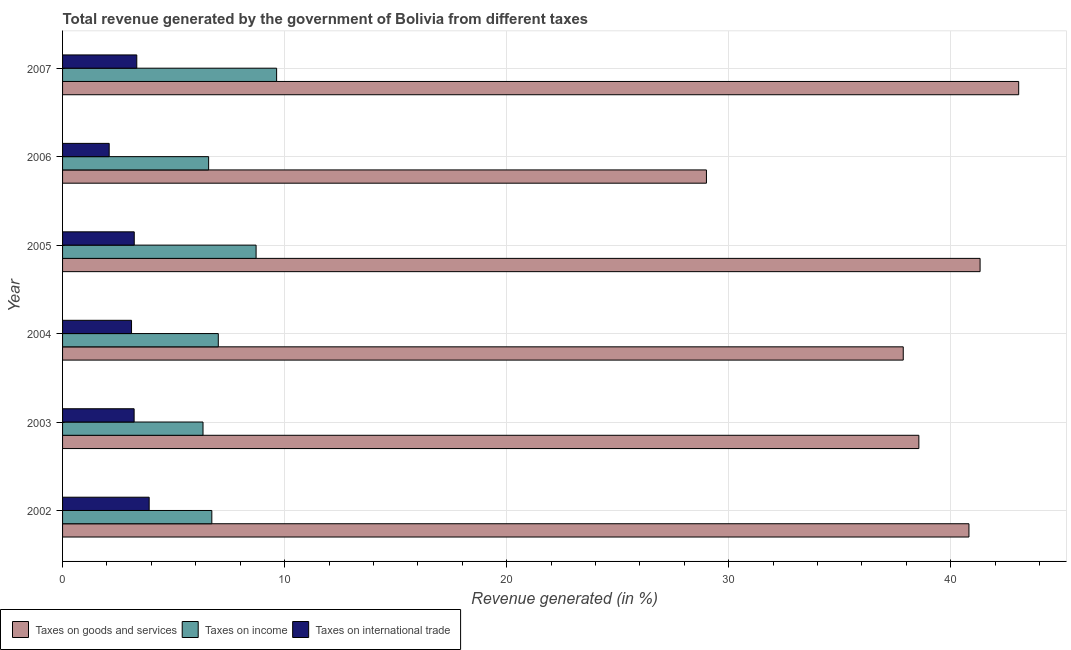How many different coloured bars are there?
Your answer should be very brief. 3. How many groups of bars are there?
Provide a succinct answer. 6. Are the number of bars on each tick of the Y-axis equal?
Give a very brief answer. Yes. How many bars are there on the 6th tick from the bottom?
Provide a succinct answer. 3. What is the label of the 2nd group of bars from the top?
Keep it short and to the point. 2006. What is the percentage of revenue generated by tax on international trade in 2003?
Your answer should be compact. 3.22. Across all years, what is the maximum percentage of revenue generated by taxes on goods and services?
Offer a very short reply. 43.06. Across all years, what is the minimum percentage of revenue generated by taxes on goods and services?
Your response must be concise. 29. What is the total percentage of revenue generated by taxes on income in the graph?
Ensure brevity in your answer.  45. What is the difference between the percentage of revenue generated by taxes on income in 2005 and that in 2007?
Your answer should be very brief. -0.93. What is the difference between the percentage of revenue generated by tax on international trade in 2006 and the percentage of revenue generated by taxes on income in 2005?
Give a very brief answer. -6.62. What is the average percentage of revenue generated by taxes on goods and services per year?
Give a very brief answer. 38.44. In the year 2006, what is the difference between the percentage of revenue generated by taxes on goods and services and percentage of revenue generated by taxes on income?
Provide a short and direct response. 22.42. In how many years, is the percentage of revenue generated by taxes on goods and services greater than 34 %?
Your response must be concise. 5. What is the ratio of the percentage of revenue generated by tax on international trade in 2005 to that in 2006?
Give a very brief answer. 1.54. What is the difference between the highest and the second highest percentage of revenue generated by tax on international trade?
Your response must be concise. 0.56. What is the difference between the highest and the lowest percentage of revenue generated by taxes on income?
Your response must be concise. 3.32. What does the 2nd bar from the top in 2006 represents?
Give a very brief answer. Taxes on income. What does the 2nd bar from the bottom in 2007 represents?
Your answer should be very brief. Taxes on income. What is the difference between two consecutive major ticks on the X-axis?
Your answer should be very brief. 10. Are the values on the major ticks of X-axis written in scientific E-notation?
Provide a succinct answer. No. How many legend labels are there?
Provide a succinct answer. 3. What is the title of the graph?
Provide a succinct answer. Total revenue generated by the government of Bolivia from different taxes. Does "Taxes" appear as one of the legend labels in the graph?
Your response must be concise. No. What is the label or title of the X-axis?
Make the answer very short. Revenue generated (in %). What is the label or title of the Y-axis?
Give a very brief answer. Year. What is the Revenue generated (in %) in Taxes on goods and services in 2002?
Offer a terse response. 40.82. What is the Revenue generated (in %) in Taxes on income in 2002?
Your answer should be very brief. 6.72. What is the Revenue generated (in %) in Taxes on international trade in 2002?
Offer a very short reply. 3.9. What is the Revenue generated (in %) in Taxes on goods and services in 2003?
Offer a very short reply. 38.57. What is the Revenue generated (in %) of Taxes on income in 2003?
Provide a short and direct response. 6.33. What is the Revenue generated (in %) of Taxes on international trade in 2003?
Your answer should be compact. 3.22. What is the Revenue generated (in %) in Taxes on goods and services in 2004?
Provide a succinct answer. 37.86. What is the Revenue generated (in %) of Taxes on income in 2004?
Offer a terse response. 7.01. What is the Revenue generated (in %) in Taxes on international trade in 2004?
Offer a very short reply. 3.11. What is the Revenue generated (in %) of Taxes on goods and services in 2005?
Offer a terse response. 41.32. What is the Revenue generated (in %) in Taxes on income in 2005?
Ensure brevity in your answer.  8.72. What is the Revenue generated (in %) of Taxes on international trade in 2005?
Make the answer very short. 3.23. What is the Revenue generated (in %) in Taxes on goods and services in 2006?
Provide a succinct answer. 29. What is the Revenue generated (in %) in Taxes on income in 2006?
Provide a short and direct response. 6.58. What is the Revenue generated (in %) of Taxes on international trade in 2006?
Offer a terse response. 2.1. What is the Revenue generated (in %) of Taxes on goods and services in 2007?
Make the answer very short. 43.06. What is the Revenue generated (in %) in Taxes on income in 2007?
Give a very brief answer. 9.64. What is the Revenue generated (in %) in Taxes on international trade in 2007?
Your response must be concise. 3.34. Across all years, what is the maximum Revenue generated (in %) in Taxes on goods and services?
Offer a very short reply. 43.06. Across all years, what is the maximum Revenue generated (in %) in Taxes on income?
Offer a very short reply. 9.64. Across all years, what is the maximum Revenue generated (in %) in Taxes on international trade?
Give a very brief answer. 3.9. Across all years, what is the minimum Revenue generated (in %) in Taxes on goods and services?
Your answer should be compact. 29. Across all years, what is the minimum Revenue generated (in %) in Taxes on income?
Provide a succinct answer. 6.33. Across all years, what is the minimum Revenue generated (in %) in Taxes on international trade?
Your answer should be very brief. 2.1. What is the total Revenue generated (in %) of Taxes on goods and services in the graph?
Your response must be concise. 230.64. What is the total Revenue generated (in %) in Taxes on income in the graph?
Your response must be concise. 45. What is the total Revenue generated (in %) in Taxes on international trade in the graph?
Keep it short and to the point. 18.9. What is the difference between the Revenue generated (in %) in Taxes on goods and services in 2002 and that in 2003?
Make the answer very short. 2.26. What is the difference between the Revenue generated (in %) of Taxes on income in 2002 and that in 2003?
Provide a succinct answer. 0.4. What is the difference between the Revenue generated (in %) in Taxes on international trade in 2002 and that in 2003?
Provide a short and direct response. 0.68. What is the difference between the Revenue generated (in %) in Taxes on goods and services in 2002 and that in 2004?
Offer a very short reply. 2.96. What is the difference between the Revenue generated (in %) of Taxes on income in 2002 and that in 2004?
Your response must be concise. -0.29. What is the difference between the Revenue generated (in %) of Taxes on international trade in 2002 and that in 2004?
Give a very brief answer. 0.79. What is the difference between the Revenue generated (in %) of Taxes on goods and services in 2002 and that in 2005?
Your answer should be compact. -0.5. What is the difference between the Revenue generated (in %) in Taxes on income in 2002 and that in 2005?
Your answer should be compact. -1.99. What is the difference between the Revenue generated (in %) in Taxes on international trade in 2002 and that in 2005?
Make the answer very short. 0.67. What is the difference between the Revenue generated (in %) of Taxes on goods and services in 2002 and that in 2006?
Ensure brevity in your answer.  11.82. What is the difference between the Revenue generated (in %) in Taxes on income in 2002 and that in 2006?
Your answer should be compact. 0.14. What is the difference between the Revenue generated (in %) of Taxes on international trade in 2002 and that in 2006?
Provide a short and direct response. 1.8. What is the difference between the Revenue generated (in %) of Taxes on goods and services in 2002 and that in 2007?
Give a very brief answer. -2.24. What is the difference between the Revenue generated (in %) of Taxes on income in 2002 and that in 2007?
Ensure brevity in your answer.  -2.92. What is the difference between the Revenue generated (in %) of Taxes on international trade in 2002 and that in 2007?
Keep it short and to the point. 0.56. What is the difference between the Revenue generated (in %) of Taxes on goods and services in 2003 and that in 2004?
Keep it short and to the point. 0.7. What is the difference between the Revenue generated (in %) of Taxes on income in 2003 and that in 2004?
Offer a terse response. -0.69. What is the difference between the Revenue generated (in %) in Taxes on international trade in 2003 and that in 2004?
Offer a very short reply. 0.12. What is the difference between the Revenue generated (in %) of Taxes on goods and services in 2003 and that in 2005?
Give a very brief answer. -2.76. What is the difference between the Revenue generated (in %) in Taxes on income in 2003 and that in 2005?
Provide a succinct answer. -2.39. What is the difference between the Revenue generated (in %) in Taxes on international trade in 2003 and that in 2005?
Offer a terse response. -0.01. What is the difference between the Revenue generated (in %) in Taxes on goods and services in 2003 and that in 2006?
Your response must be concise. 9.57. What is the difference between the Revenue generated (in %) in Taxes on income in 2003 and that in 2006?
Offer a very short reply. -0.25. What is the difference between the Revenue generated (in %) in Taxes on international trade in 2003 and that in 2006?
Provide a succinct answer. 1.12. What is the difference between the Revenue generated (in %) in Taxes on goods and services in 2003 and that in 2007?
Keep it short and to the point. -4.5. What is the difference between the Revenue generated (in %) in Taxes on income in 2003 and that in 2007?
Your answer should be very brief. -3.32. What is the difference between the Revenue generated (in %) of Taxes on international trade in 2003 and that in 2007?
Offer a terse response. -0.12. What is the difference between the Revenue generated (in %) of Taxes on goods and services in 2004 and that in 2005?
Your answer should be very brief. -3.46. What is the difference between the Revenue generated (in %) of Taxes on income in 2004 and that in 2005?
Your answer should be compact. -1.7. What is the difference between the Revenue generated (in %) in Taxes on international trade in 2004 and that in 2005?
Offer a very short reply. -0.12. What is the difference between the Revenue generated (in %) of Taxes on goods and services in 2004 and that in 2006?
Provide a short and direct response. 8.86. What is the difference between the Revenue generated (in %) in Taxes on income in 2004 and that in 2006?
Ensure brevity in your answer.  0.44. What is the difference between the Revenue generated (in %) of Taxes on goods and services in 2004 and that in 2007?
Your answer should be compact. -5.2. What is the difference between the Revenue generated (in %) of Taxes on income in 2004 and that in 2007?
Offer a very short reply. -2.63. What is the difference between the Revenue generated (in %) in Taxes on international trade in 2004 and that in 2007?
Your answer should be compact. -0.24. What is the difference between the Revenue generated (in %) in Taxes on goods and services in 2005 and that in 2006?
Offer a terse response. 12.32. What is the difference between the Revenue generated (in %) in Taxes on income in 2005 and that in 2006?
Provide a succinct answer. 2.14. What is the difference between the Revenue generated (in %) of Taxes on international trade in 2005 and that in 2006?
Provide a succinct answer. 1.13. What is the difference between the Revenue generated (in %) of Taxes on goods and services in 2005 and that in 2007?
Your answer should be compact. -1.74. What is the difference between the Revenue generated (in %) in Taxes on income in 2005 and that in 2007?
Make the answer very short. -0.93. What is the difference between the Revenue generated (in %) in Taxes on international trade in 2005 and that in 2007?
Your answer should be compact. -0.11. What is the difference between the Revenue generated (in %) of Taxes on goods and services in 2006 and that in 2007?
Provide a succinct answer. -14.06. What is the difference between the Revenue generated (in %) in Taxes on income in 2006 and that in 2007?
Give a very brief answer. -3.06. What is the difference between the Revenue generated (in %) in Taxes on international trade in 2006 and that in 2007?
Give a very brief answer. -1.24. What is the difference between the Revenue generated (in %) in Taxes on goods and services in 2002 and the Revenue generated (in %) in Taxes on income in 2003?
Keep it short and to the point. 34.5. What is the difference between the Revenue generated (in %) in Taxes on goods and services in 2002 and the Revenue generated (in %) in Taxes on international trade in 2003?
Keep it short and to the point. 37.6. What is the difference between the Revenue generated (in %) of Taxes on income in 2002 and the Revenue generated (in %) of Taxes on international trade in 2003?
Your answer should be very brief. 3.5. What is the difference between the Revenue generated (in %) in Taxes on goods and services in 2002 and the Revenue generated (in %) in Taxes on income in 2004?
Ensure brevity in your answer.  33.81. What is the difference between the Revenue generated (in %) of Taxes on goods and services in 2002 and the Revenue generated (in %) of Taxes on international trade in 2004?
Your answer should be compact. 37.72. What is the difference between the Revenue generated (in %) of Taxes on income in 2002 and the Revenue generated (in %) of Taxes on international trade in 2004?
Make the answer very short. 3.62. What is the difference between the Revenue generated (in %) of Taxes on goods and services in 2002 and the Revenue generated (in %) of Taxes on income in 2005?
Your answer should be very brief. 32.11. What is the difference between the Revenue generated (in %) of Taxes on goods and services in 2002 and the Revenue generated (in %) of Taxes on international trade in 2005?
Offer a very short reply. 37.59. What is the difference between the Revenue generated (in %) of Taxes on income in 2002 and the Revenue generated (in %) of Taxes on international trade in 2005?
Your response must be concise. 3.49. What is the difference between the Revenue generated (in %) of Taxes on goods and services in 2002 and the Revenue generated (in %) of Taxes on income in 2006?
Provide a succinct answer. 34.24. What is the difference between the Revenue generated (in %) of Taxes on goods and services in 2002 and the Revenue generated (in %) of Taxes on international trade in 2006?
Your answer should be very brief. 38.72. What is the difference between the Revenue generated (in %) in Taxes on income in 2002 and the Revenue generated (in %) in Taxes on international trade in 2006?
Offer a terse response. 4.62. What is the difference between the Revenue generated (in %) of Taxes on goods and services in 2002 and the Revenue generated (in %) of Taxes on income in 2007?
Give a very brief answer. 31.18. What is the difference between the Revenue generated (in %) in Taxes on goods and services in 2002 and the Revenue generated (in %) in Taxes on international trade in 2007?
Offer a very short reply. 37.48. What is the difference between the Revenue generated (in %) in Taxes on income in 2002 and the Revenue generated (in %) in Taxes on international trade in 2007?
Ensure brevity in your answer.  3.38. What is the difference between the Revenue generated (in %) of Taxes on goods and services in 2003 and the Revenue generated (in %) of Taxes on income in 2004?
Offer a terse response. 31.55. What is the difference between the Revenue generated (in %) of Taxes on goods and services in 2003 and the Revenue generated (in %) of Taxes on international trade in 2004?
Offer a terse response. 35.46. What is the difference between the Revenue generated (in %) of Taxes on income in 2003 and the Revenue generated (in %) of Taxes on international trade in 2004?
Give a very brief answer. 3.22. What is the difference between the Revenue generated (in %) in Taxes on goods and services in 2003 and the Revenue generated (in %) in Taxes on income in 2005?
Provide a short and direct response. 29.85. What is the difference between the Revenue generated (in %) of Taxes on goods and services in 2003 and the Revenue generated (in %) of Taxes on international trade in 2005?
Provide a succinct answer. 35.34. What is the difference between the Revenue generated (in %) of Taxes on income in 2003 and the Revenue generated (in %) of Taxes on international trade in 2005?
Offer a terse response. 3.1. What is the difference between the Revenue generated (in %) of Taxes on goods and services in 2003 and the Revenue generated (in %) of Taxes on income in 2006?
Ensure brevity in your answer.  31.99. What is the difference between the Revenue generated (in %) of Taxes on goods and services in 2003 and the Revenue generated (in %) of Taxes on international trade in 2006?
Give a very brief answer. 36.47. What is the difference between the Revenue generated (in %) of Taxes on income in 2003 and the Revenue generated (in %) of Taxes on international trade in 2006?
Your answer should be compact. 4.23. What is the difference between the Revenue generated (in %) of Taxes on goods and services in 2003 and the Revenue generated (in %) of Taxes on income in 2007?
Ensure brevity in your answer.  28.93. What is the difference between the Revenue generated (in %) of Taxes on goods and services in 2003 and the Revenue generated (in %) of Taxes on international trade in 2007?
Offer a very short reply. 35.22. What is the difference between the Revenue generated (in %) in Taxes on income in 2003 and the Revenue generated (in %) in Taxes on international trade in 2007?
Keep it short and to the point. 2.98. What is the difference between the Revenue generated (in %) of Taxes on goods and services in 2004 and the Revenue generated (in %) of Taxes on income in 2005?
Provide a succinct answer. 29.15. What is the difference between the Revenue generated (in %) in Taxes on goods and services in 2004 and the Revenue generated (in %) in Taxes on international trade in 2005?
Your answer should be compact. 34.63. What is the difference between the Revenue generated (in %) of Taxes on income in 2004 and the Revenue generated (in %) of Taxes on international trade in 2005?
Your response must be concise. 3.79. What is the difference between the Revenue generated (in %) of Taxes on goods and services in 2004 and the Revenue generated (in %) of Taxes on income in 2006?
Offer a very short reply. 31.28. What is the difference between the Revenue generated (in %) of Taxes on goods and services in 2004 and the Revenue generated (in %) of Taxes on international trade in 2006?
Offer a terse response. 35.76. What is the difference between the Revenue generated (in %) of Taxes on income in 2004 and the Revenue generated (in %) of Taxes on international trade in 2006?
Offer a very short reply. 4.91. What is the difference between the Revenue generated (in %) in Taxes on goods and services in 2004 and the Revenue generated (in %) in Taxes on income in 2007?
Offer a very short reply. 28.22. What is the difference between the Revenue generated (in %) in Taxes on goods and services in 2004 and the Revenue generated (in %) in Taxes on international trade in 2007?
Keep it short and to the point. 34.52. What is the difference between the Revenue generated (in %) of Taxes on income in 2004 and the Revenue generated (in %) of Taxes on international trade in 2007?
Offer a very short reply. 3.67. What is the difference between the Revenue generated (in %) of Taxes on goods and services in 2005 and the Revenue generated (in %) of Taxes on income in 2006?
Offer a terse response. 34.75. What is the difference between the Revenue generated (in %) in Taxes on goods and services in 2005 and the Revenue generated (in %) in Taxes on international trade in 2006?
Offer a very short reply. 39.22. What is the difference between the Revenue generated (in %) of Taxes on income in 2005 and the Revenue generated (in %) of Taxes on international trade in 2006?
Your answer should be compact. 6.62. What is the difference between the Revenue generated (in %) in Taxes on goods and services in 2005 and the Revenue generated (in %) in Taxes on income in 2007?
Offer a terse response. 31.68. What is the difference between the Revenue generated (in %) in Taxes on goods and services in 2005 and the Revenue generated (in %) in Taxes on international trade in 2007?
Give a very brief answer. 37.98. What is the difference between the Revenue generated (in %) of Taxes on income in 2005 and the Revenue generated (in %) of Taxes on international trade in 2007?
Keep it short and to the point. 5.37. What is the difference between the Revenue generated (in %) of Taxes on goods and services in 2006 and the Revenue generated (in %) of Taxes on income in 2007?
Keep it short and to the point. 19.36. What is the difference between the Revenue generated (in %) in Taxes on goods and services in 2006 and the Revenue generated (in %) in Taxes on international trade in 2007?
Provide a succinct answer. 25.66. What is the difference between the Revenue generated (in %) of Taxes on income in 2006 and the Revenue generated (in %) of Taxes on international trade in 2007?
Make the answer very short. 3.24. What is the average Revenue generated (in %) of Taxes on goods and services per year?
Keep it short and to the point. 38.44. What is the average Revenue generated (in %) in Taxes on income per year?
Provide a short and direct response. 7.5. What is the average Revenue generated (in %) in Taxes on international trade per year?
Your answer should be very brief. 3.15. In the year 2002, what is the difference between the Revenue generated (in %) of Taxes on goods and services and Revenue generated (in %) of Taxes on income?
Offer a terse response. 34.1. In the year 2002, what is the difference between the Revenue generated (in %) in Taxes on goods and services and Revenue generated (in %) in Taxes on international trade?
Give a very brief answer. 36.92. In the year 2002, what is the difference between the Revenue generated (in %) of Taxes on income and Revenue generated (in %) of Taxes on international trade?
Provide a short and direct response. 2.82. In the year 2003, what is the difference between the Revenue generated (in %) in Taxes on goods and services and Revenue generated (in %) in Taxes on income?
Ensure brevity in your answer.  32.24. In the year 2003, what is the difference between the Revenue generated (in %) in Taxes on goods and services and Revenue generated (in %) in Taxes on international trade?
Ensure brevity in your answer.  35.34. In the year 2003, what is the difference between the Revenue generated (in %) of Taxes on income and Revenue generated (in %) of Taxes on international trade?
Give a very brief answer. 3.1. In the year 2004, what is the difference between the Revenue generated (in %) in Taxes on goods and services and Revenue generated (in %) in Taxes on income?
Provide a succinct answer. 30.85. In the year 2004, what is the difference between the Revenue generated (in %) of Taxes on goods and services and Revenue generated (in %) of Taxes on international trade?
Provide a succinct answer. 34.76. In the year 2004, what is the difference between the Revenue generated (in %) in Taxes on income and Revenue generated (in %) in Taxes on international trade?
Your answer should be very brief. 3.91. In the year 2005, what is the difference between the Revenue generated (in %) in Taxes on goods and services and Revenue generated (in %) in Taxes on income?
Provide a succinct answer. 32.61. In the year 2005, what is the difference between the Revenue generated (in %) in Taxes on goods and services and Revenue generated (in %) in Taxes on international trade?
Your answer should be very brief. 38.09. In the year 2005, what is the difference between the Revenue generated (in %) of Taxes on income and Revenue generated (in %) of Taxes on international trade?
Give a very brief answer. 5.49. In the year 2006, what is the difference between the Revenue generated (in %) of Taxes on goods and services and Revenue generated (in %) of Taxes on income?
Make the answer very short. 22.42. In the year 2006, what is the difference between the Revenue generated (in %) of Taxes on goods and services and Revenue generated (in %) of Taxes on international trade?
Offer a terse response. 26.9. In the year 2006, what is the difference between the Revenue generated (in %) of Taxes on income and Revenue generated (in %) of Taxes on international trade?
Provide a succinct answer. 4.48. In the year 2007, what is the difference between the Revenue generated (in %) in Taxes on goods and services and Revenue generated (in %) in Taxes on income?
Offer a terse response. 33.42. In the year 2007, what is the difference between the Revenue generated (in %) of Taxes on goods and services and Revenue generated (in %) of Taxes on international trade?
Provide a short and direct response. 39.72. In the year 2007, what is the difference between the Revenue generated (in %) of Taxes on income and Revenue generated (in %) of Taxes on international trade?
Offer a very short reply. 6.3. What is the ratio of the Revenue generated (in %) in Taxes on goods and services in 2002 to that in 2003?
Keep it short and to the point. 1.06. What is the ratio of the Revenue generated (in %) in Taxes on income in 2002 to that in 2003?
Offer a terse response. 1.06. What is the ratio of the Revenue generated (in %) of Taxes on international trade in 2002 to that in 2003?
Give a very brief answer. 1.21. What is the ratio of the Revenue generated (in %) in Taxes on goods and services in 2002 to that in 2004?
Provide a short and direct response. 1.08. What is the ratio of the Revenue generated (in %) of Taxes on income in 2002 to that in 2004?
Provide a succinct answer. 0.96. What is the ratio of the Revenue generated (in %) of Taxes on international trade in 2002 to that in 2004?
Make the answer very short. 1.26. What is the ratio of the Revenue generated (in %) of Taxes on goods and services in 2002 to that in 2005?
Keep it short and to the point. 0.99. What is the ratio of the Revenue generated (in %) in Taxes on income in 2002 to that in 2005?
Make the answer very short. 0.77. What is the ratio of the Revenue generated (in %) in Taxes on international trade in 2002 to that in 2005?
Ensure brevity in your answer.  1.21. What is the ratio of the Revenue generated (in %) of Taxes on goods and services in 2002 to that in 2006?
Your answer should be very brief. 1.41. What is the ratio of the Revenue generated (in %) in Taxes on income in 2002 to that in 2006?
Make the answer very short. 1.02. What is the ratio of the Revenue generated (in %) of Taxes on international trade in 2002 to that in 2006?
Provide a succinct answer. 1.86. What is the ratio of the Revenue generated (in %) in Taxes on goods and services in 2002 to that in 2007?
Your answer should be compact. 0.95. What is the ratio of the Revenue generated (in %) in Taxes on income in 2002 to that in 2007?
Ensure brevity in your answer.  0.7. What is the ratio of the Revenue generated (in %) in Taxes on international trade in 2002 to that in 2007?
Ensure brevity in your answer.  1.17. What is the ratio of the Revenue generated (in %) in Taxes on goods and services in 2003 to that in 2004?
Give a very brief answer. 1.02. What is the ratio of the Revenue generated (in %) of Taxes on income in 2003 to that in 2004?
Provide a short and direct response. 0.9. What is the ratio of the Revenue generated (in %) of Taxes on international trade in 2003 to that in 2004?
Offer a very short reply. 1.04. What is the ratio of the Revenue generated (in %) of Taxes on goods and services in 2003 to that in 2005?
Offer a very short reply. 0.93. What is the ratio of the Revenue generated (in %) in Taxes on income in 2003 to that in 2005?
Give a very brief answer. 0.73. What is the ratio of the Revenue generated (in %) in Taxes on international trade in 2003 to that in 2005?
Your response must be concise. 1. What is the ratio of the Revenue generated (in %) of Taxes on goods and services in 2003 to that in 2006?
Keep it short and to the point. 1.33. What is the ratio of the Revenue generated (in %) of Taxes on income in 2003 to that in 2006?
Give a very brief answer. 0.96. What is the ratio of the Revenue generated (in %) of Taxes on international trade in 2003 to that in 2006?
Your answer should be compact. 1.53. What is the ratio of the Revenue generated (in %) of Taxes on goods and services in 2003 to that in 2007?
Make the answer very short. 0.9. What is the ratio of the Revenue generated (in %) in Taxes on income in 2003 to that in 2007?
Your answer should be very brief. 0.66. What is the ratio of the Revenue generated (in %) of Taxes on goods and services in 2004 to that in 2005?
Your answer should be compact. 0.92. What is the ratio of the Revenue generated (in %) in Taxes on income in 2004 to that in 2005?
Offer a very short reply. 0.8. What is the ratio of the Revenue generated (in %) of Taxes on goods and services in 2004 to that in 2006?
Make the answer very short. 1.31. What is the ratio of the Revenue generated (in %) of Taxes on income in 2004 to that in 2006?
Your answer should be very brief. 1.07. What is the ratio of the Revenue generated (in %) in Taxes on international trade in 2004 to that in 2006?
Keep it short and to the point. 1.48. What is the ratio of the Revenue generated (in %) in Taxes on goods and services in 2004 to that in 2007?
Your response must be concise. 0.88. What is the ratio of the Revenue generated (in %) of Taxes on income in 2004 to that in 2007?
Offer a very short reply. 0.73. What is the ratio of the Revenue generated (in %) in Taxes on international trade in 2004 to that in 2007?
Your response must be concise. 0.93. What is the ratio of the Revenue generated (in %) in Taxes on goods and services in 2005 to that in 2006?
Your response must be concise. 1.43. What is the ratio of the Revenue generated (in %) of Taxes on income in 2005 to that in 2006?
Offer a very short reply. 1.32. What is the ratio of the Revenue generated (in %) of Taxes on international trade in 2005 to that in 2006?
Give a very brief answer. 1.54. What is the ratio of the Revenue generated (in %) of Taxes on goods and services in 2005 to that in 2007?
Provide a short and direct response. 0.96. What is the ratio of the Revenue generated (in %) of Taxes on income in 2005 to that in 2007?
Offer a very short reply. 0.9. What is the ratio of the Revenue generated (in %) in Taxes on international trade in 2005 to that in 2007?
Keep it short and to the point. 0.97. What is the ratio of the Revenue generated (in %) in Taxes on goods and services in 2006 to that in 2007?
Your answer should be very brief. 0.67. What is the ratio of the Revenue generated (in %) in Taxes on income in 2006 to that in 2007?
Ensure brevity in your answer.  0.68. What is the ratio of the Revenue generated (in %) of Taxes on international trade in 2006 to that in 2007?
Give a very brief answer. 0.63. What is the difference between the highest and the second highest Revenue generated (in %) of Taxes on goods and services?
Make the answer very short. 1.74. What is the difference between the highest and the second highest Revenue generated (in %) of Taxes on income?
Provide a succinct answer. 0.93. What is the difference between the highest and the second highest Revenue generated (in %) in Taxes on international trade?
Your answer should be very brief. 0.56. What is the difference between the highest and the lowest Revenue generated (in %) of Taxes on goods and services?
Make the answer very short. 14.06. What is the difference between the highest and the lowest Revenue generated (in %) in Taxes on income?
Ensure brevity in your answer.  3.32. What is the difference between the highest and the lowest Revenue generated (in %) in Taxes on international trade?
Keep it short and to the point. 1.8. 